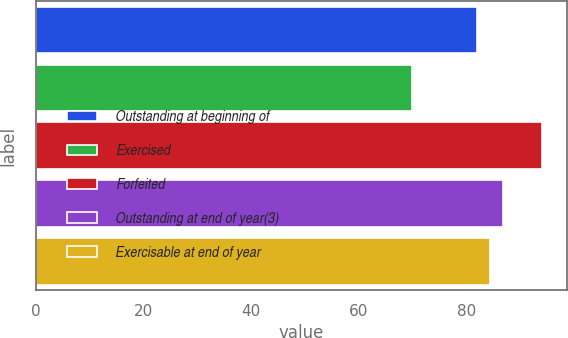Convert chart to OTSL. <chart><loc_0><loc_0><loc_500><loc_500><bar_chart><fcel>Outstanding at beginning of<fcel>Exercised<fcel>Forfeited<fcel>Outstanding at end of year(3)<fcel>Exercisable at end of year<nl><fcel>82<fcel>70<fcel>94<fcel>86.8<fcel>84.4<nl></chart> 